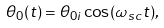<formula> <loc_0><loc_0><loc_500><loc_500>\theta _ { 0 } ( t ) = \theta _ { 0 i } \cos ( \omega _ { s c } t ) ,</formula> 